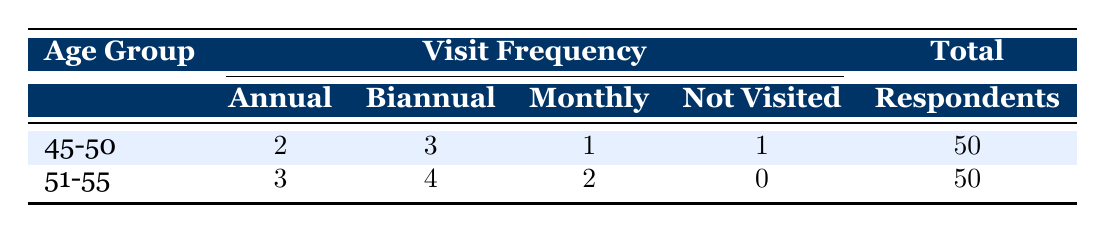What is the total number of respondents in the age group 45-50? The table indicates that there are 50 respondents in the age group 45-50, as shown in the "Total" column corresponding to that age group.
Answer: 50 How many respondents in the age group 51-55 visit the dentist biannually? Referring to the "Biannual" column for the age group 51-55, the value is 4, meaning 4 respondents visit the dentist biannually.
Answer: 4 What is the total number of respondents who have not visited the dentist across both age groups? To find this, we look at the "Not Visited" values for both age groups. For 45-50, it's 1, and for 51-55, it's 0. So the total is 1 + 0 = 1.
Answer: 1 Which age group has the highest frequency of monthly dental visits? Looking at the "Monthly" column, the age group 51-55 has a value of 2, while 45-50 has a value of 1. Thus, 51-55 has the highest frequency of monthly visits.
Answer: 51-55 What is the total combined frequency of annual visits for both age groups? To calculate this, we add the "Annual" values for both age groups: 2 (from 45-50) + 3 (from 51-55) = 5.
Answer: 5 Are there any respondents in the 51-55 age group who have not visited the dentist? In the "Not Visited" column for the age group 51-55, the value is 0, indicating there are no respondents who have not visited the dentist.
Answer: No What percentage of the total respondents in the 45-50 age group visit the dentist monthly? There are 50 respondents in the 45-50 age group, and 1 visits monthly. To calculate the percentage: (1 / 50) * 100 = 2%.
Answer: 2% How many total dental visits (annual + biannual + monthly) are reported by the age group 45-50? We sum the values in the "Annual", "Biannual", and "Monthly" columns for the age group 45-50: 2 (annual) + 3 (biannual) + 1 (monthly) = 6 total visits.
Answer: 6 Which age group has a higher combined frequency of annual and biannual visits? First, we calculate the combined frequency for each age group: for 45-50, it is 2 (annual) + 3 (biannual) = 5; for 51-55, it is 3 (annual) + 4 (biannual) = 7. Since 7 is greater than 5, the 51-55 age group has a higher combined frequency.
Answer: 51-55 